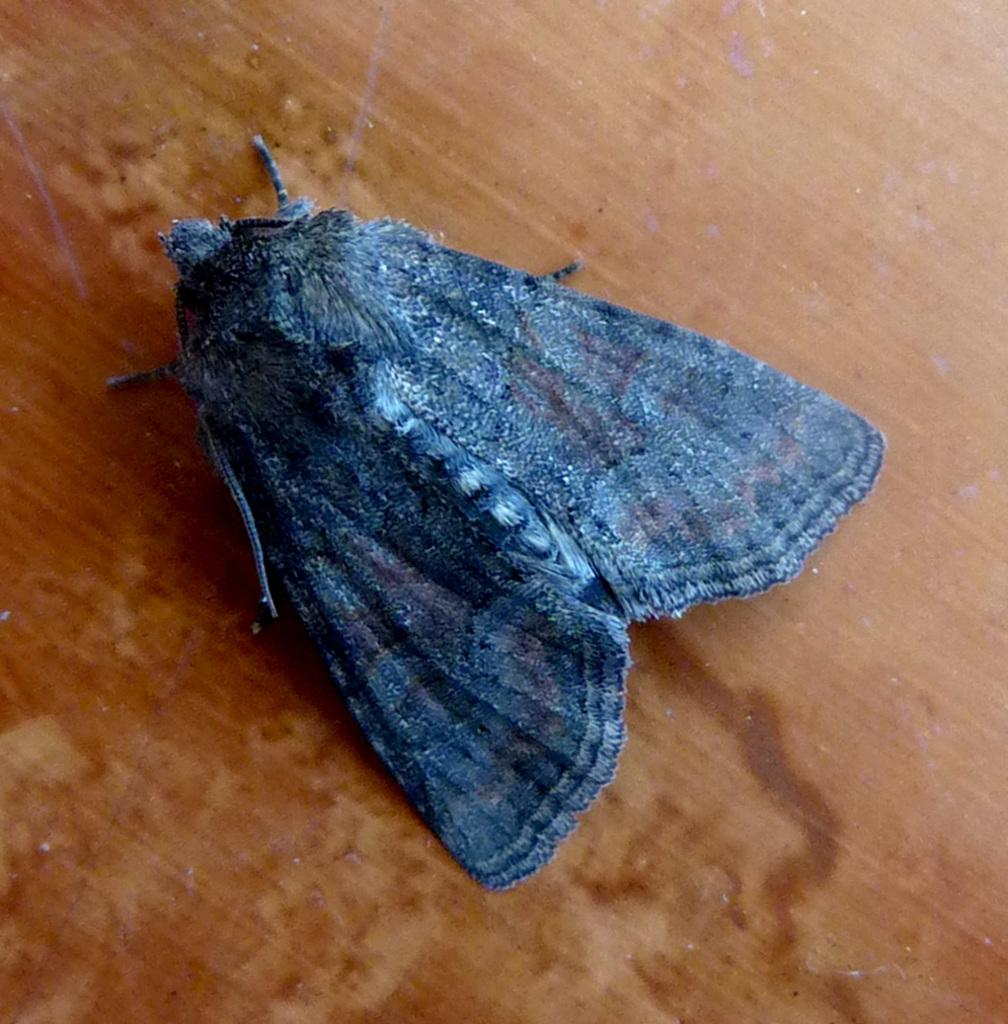What is the main subject in the foreground of the image? There is an insect in the foreground of the image. What is the insect doing or resting on in the image? The insect is on a surface in the image. What type of authority does the insect have in the image? The insect does not have any authority in the image, as it is a living organism and not a person or entity with power or influence. 